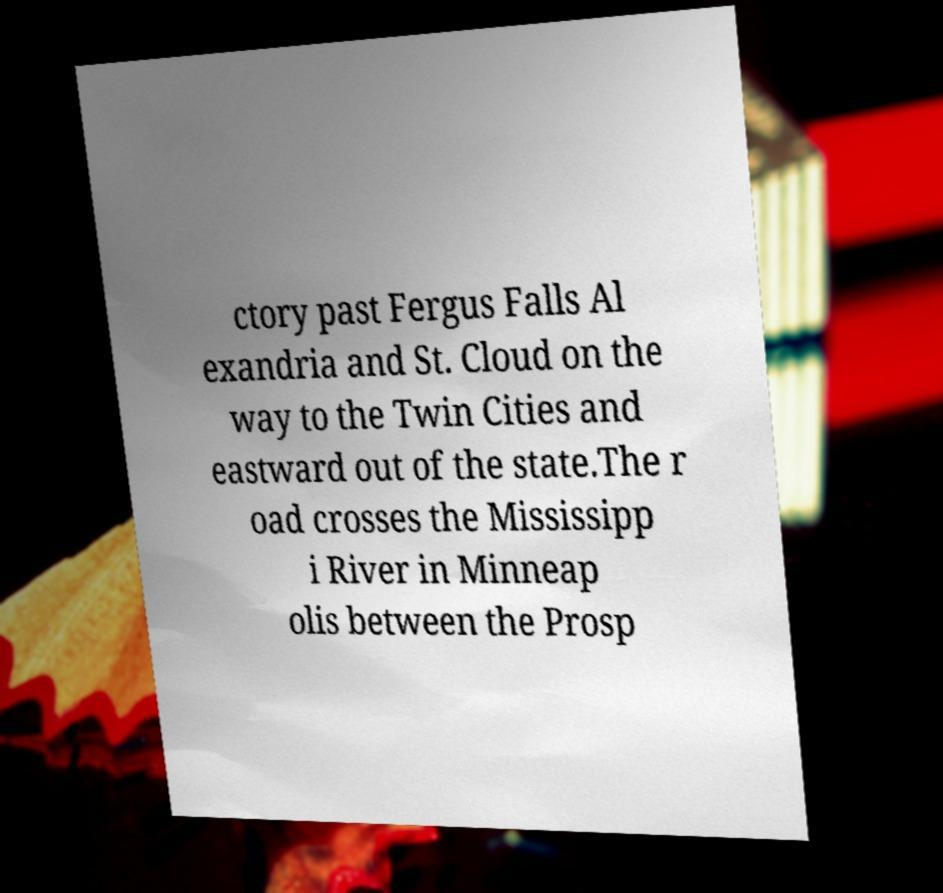Can you accurately transcribe the text from the provided image for me? ctory past Fergus Falls Al exandria and St. Cloud on the way to the Twin Cities and eastward out of the state.The r oad crosses the Mississipp i River in Minneap olis between the Prosp 